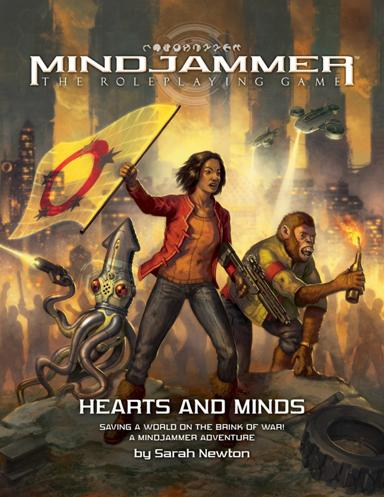What themes might be explored based on the visual elements seen here? Based on the visual elements, 'Mindjammer' seems to delve into themes of rebellion, cultural integration, and technological ethics. The vibrant, chaotic backdrop mixed with armed characters and tense expressions indicates a conflict where old meets new, perhaps challenging moral dilemmas about technology's role in society and warfare. The diverse characters further suggest themes of unity and diversity in facing common threats. 